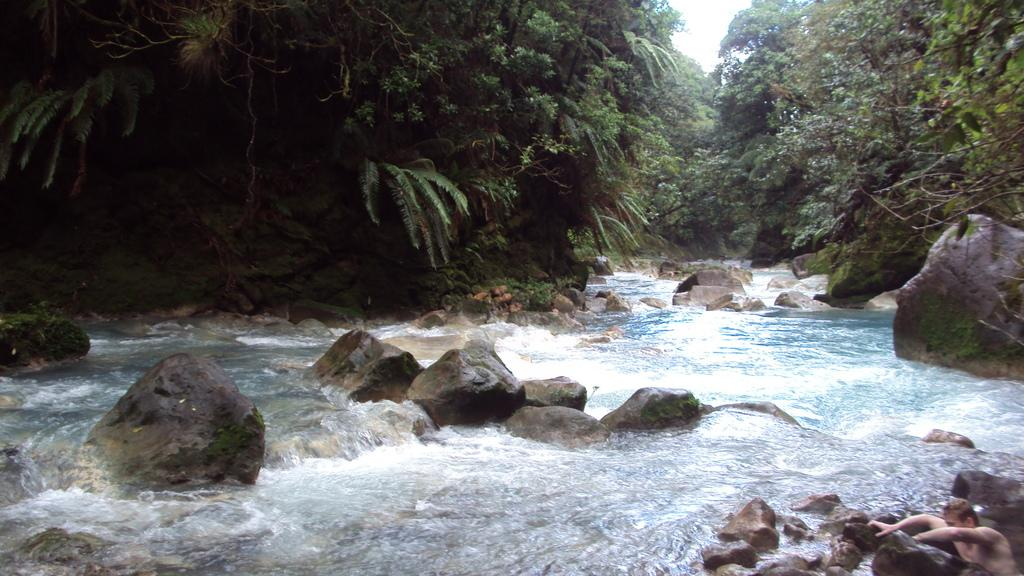What is the primary element in the image? There is water in the image. What can be seen in the water? There are many rocks in the water. What type of vegetation is visible in the image? There are trees visible in the image. What is the color of the sky in the background of the image? The sky is white in the background of the image. Where is the meeting taking place in the image? There is no meeting present in the image; it features water, rocks, trees, and a white sky. What title is given to the group of ducks in the image? There are no ducks present in the image, so there is no title for a group of ducks. 